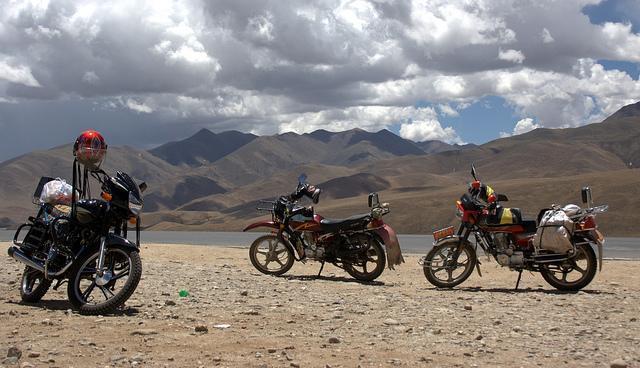How many motorcycles are there?
Give a very brief answer. 3. 